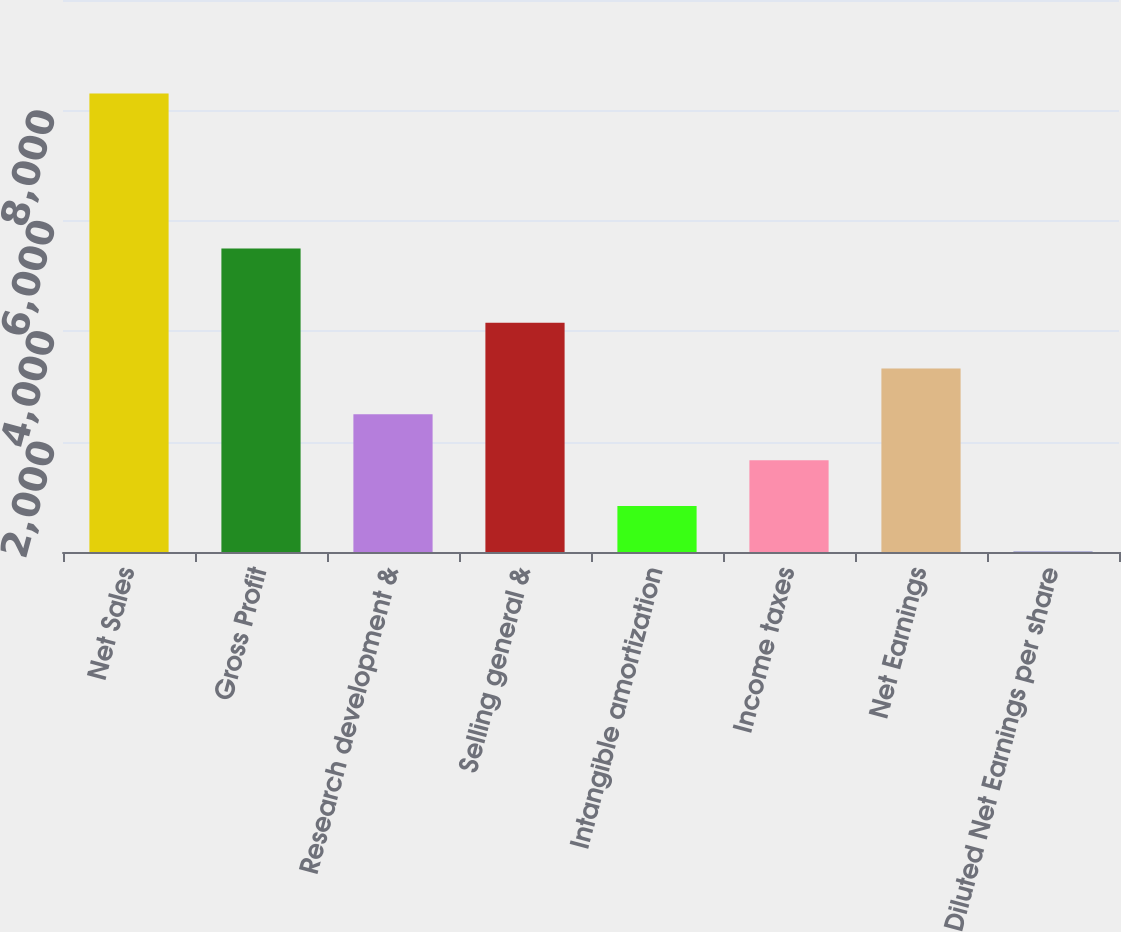<chart> <loc_0><loc_0><loc_500><loc_500><bar_chart><fcel>Net Sales<fcel>Gross Profit<fcel>Research development &<fcel>Selling general &<fcel>Intangible amortization<fcel>Income taxes<fcel>Net Earnings<fcel>Diluted Net Earnings per share<nl><fcel>8307<fcel>5496<fcel>2494.52<fcel>4155.24<fcel>833.81<fcel>1664.16<fcel>3324.88<fcel>3.45<nl></chart> 